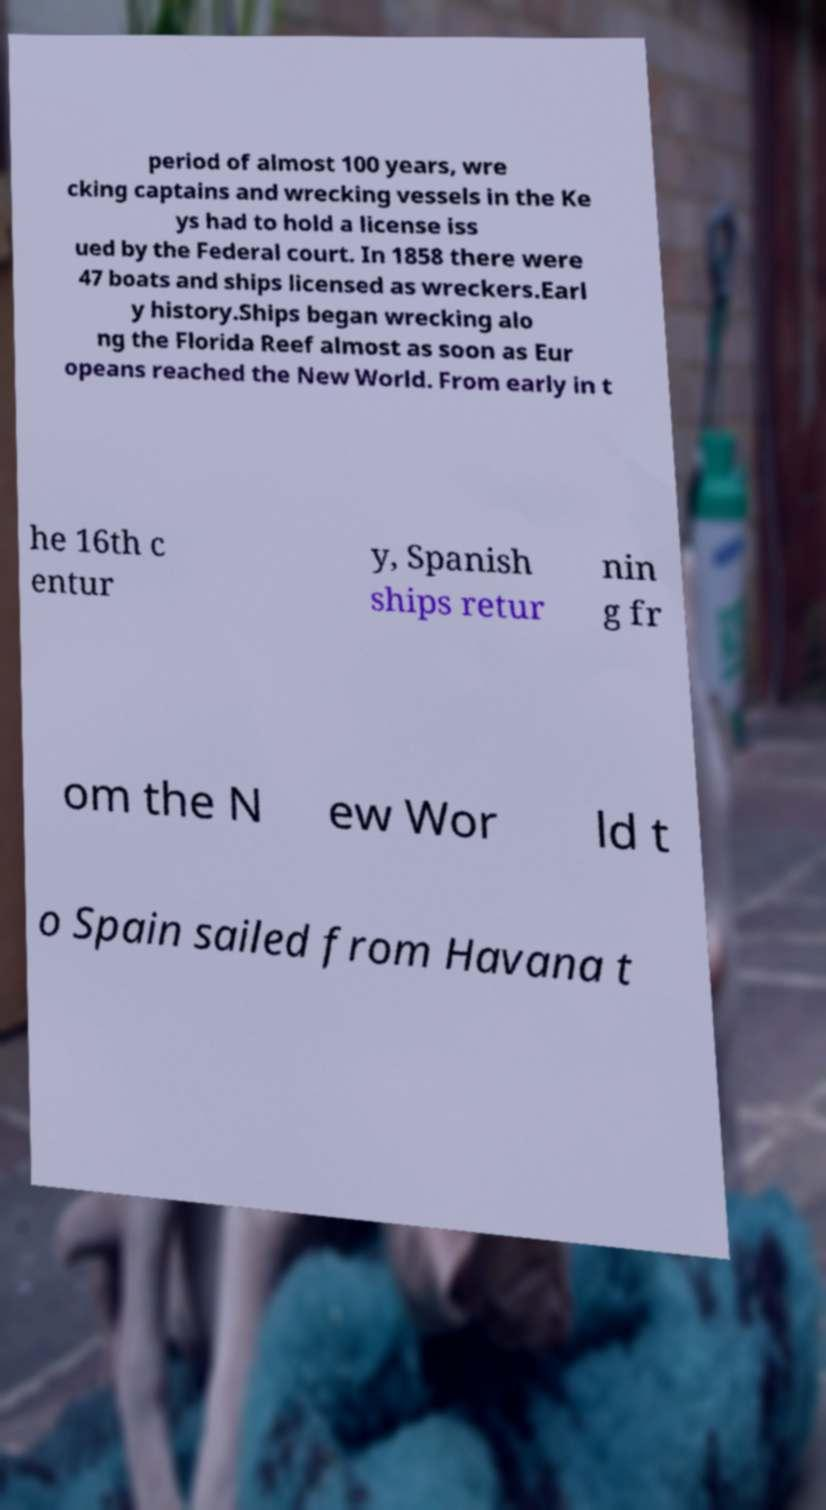Can you read and provide the text displayed in the image?This photo seems to have some interesting text. Can you extract and type it out for me? period of almost 100 years, wre cking captains and wrecking vessels in the Ke ys had to hold a license iss ued by the Federal court. In 1858 there were 47 boats and ships licensed as wreckers.Earl y history.Ships began wrecking alo ng the Florida Reef almost as soon as Eur opeans reached the New World. From early in t he 16th c entur y, Spanish ships retur nin g fr om the N ew Wor ld t o Spain sailed from Havana t 